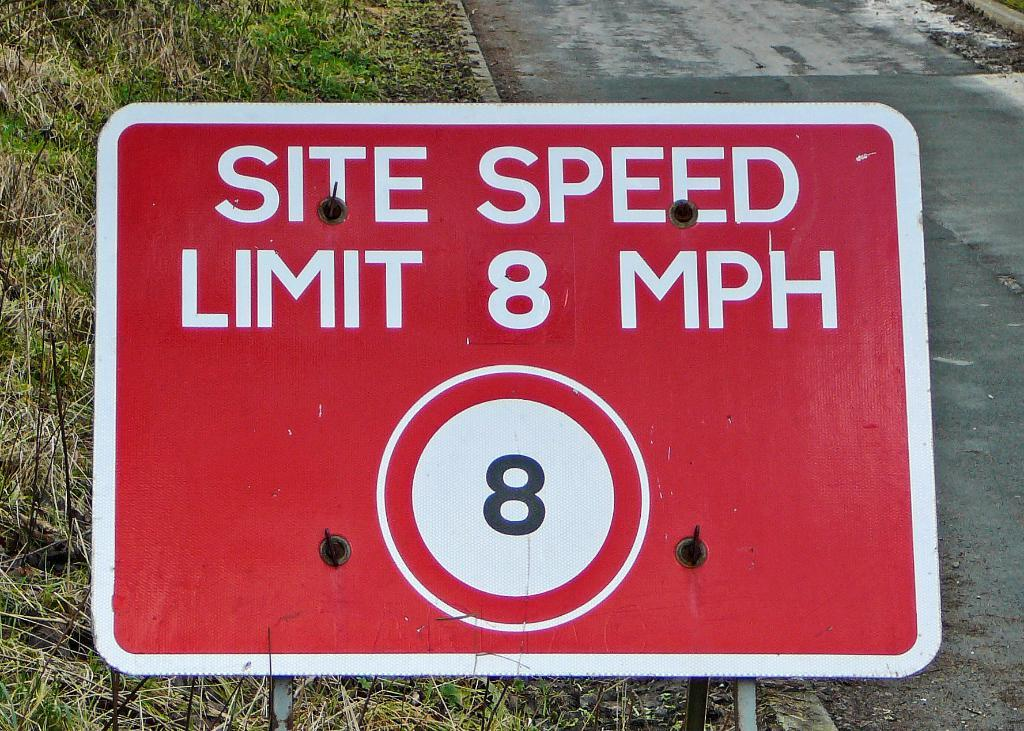Provide a one-sentence caption for the provided image. Road sign that says site speed limit eight mph. 